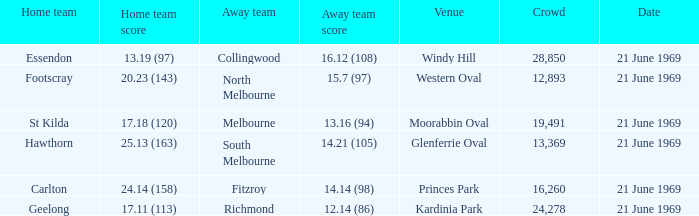When did an away team score 15.7 (97)? 21 June 1969. 